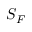Convert formula to latex. <formula><loc_0><loc_0><loc_500><loc_500>S _ { F }</formula> 